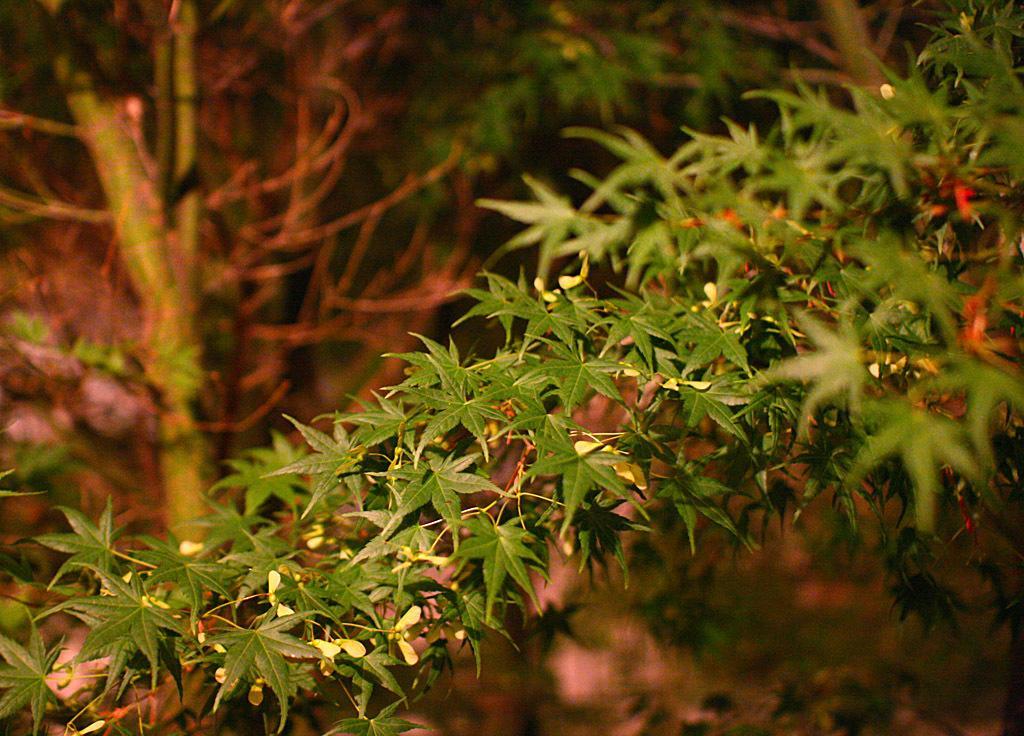Please provide a concise description of this image. In this image there is a plant with tiny flowers, and in the background there are plants. 